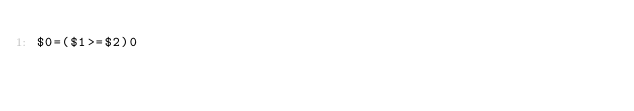<code> <loc_0><loc_0><loc_500><loc_500><_Awk_>$0=($1>=$2)0</code> 